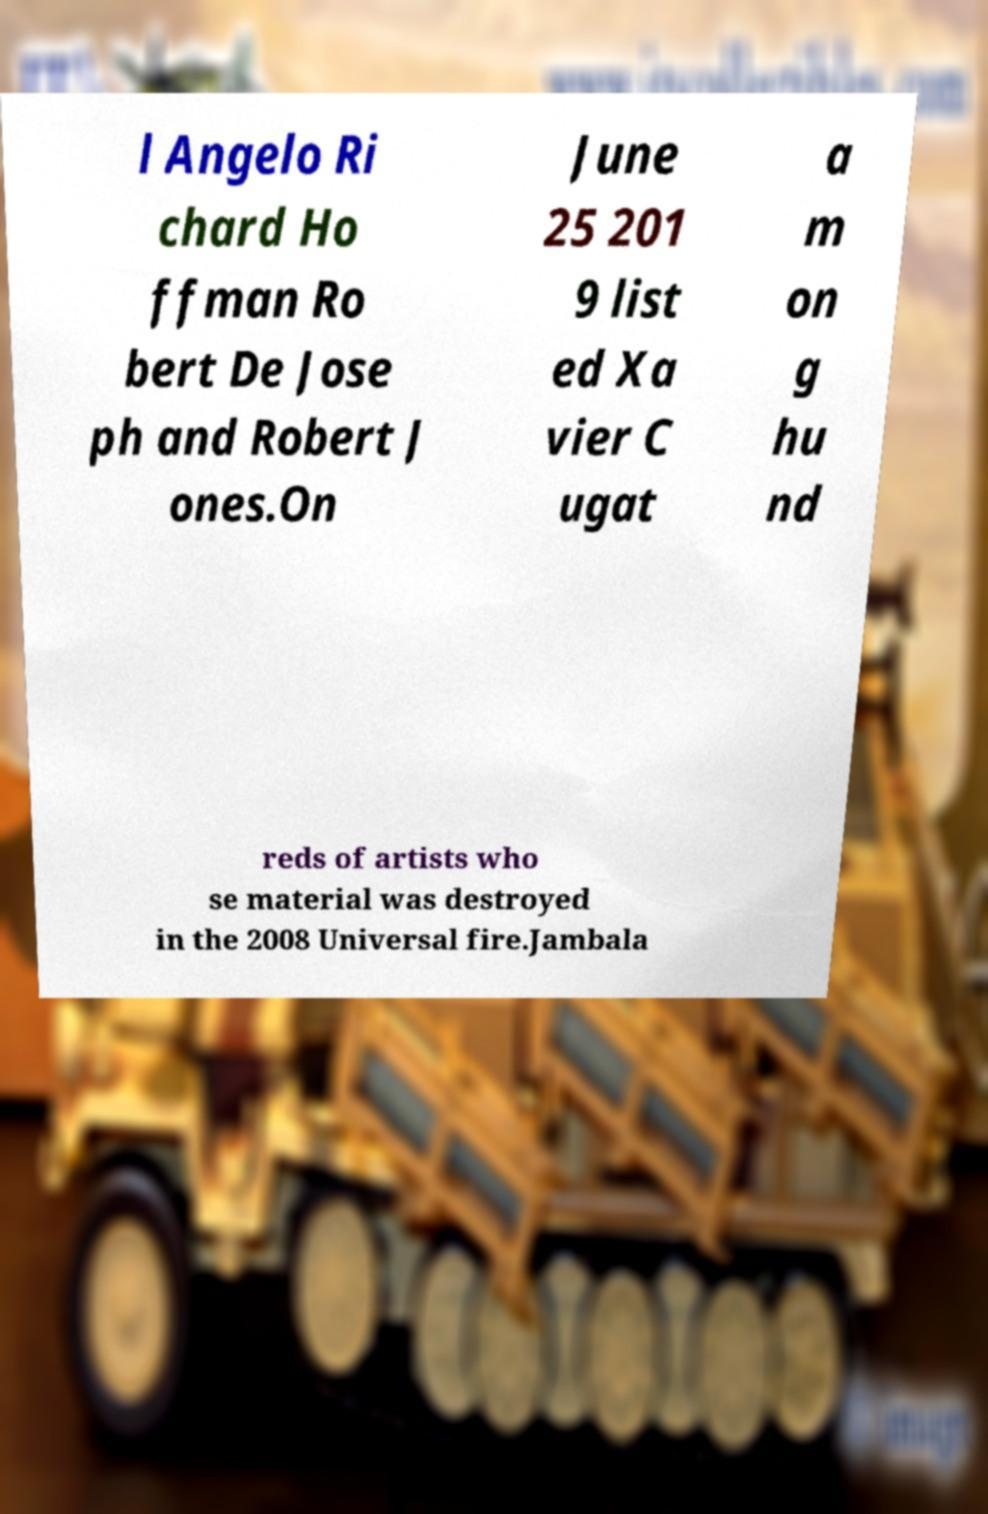For documentation purposes, I need the text within this image transcribed. Could you provide that? l Angelo Ri chard Ho ffman Ro bert De Jose ph and Robert J ones.On June 25 201 9 list ed Xa vier C ugat a m on g hu nd reds of artists who se material was destroyed in the 2008 Universal fire.Jambala 